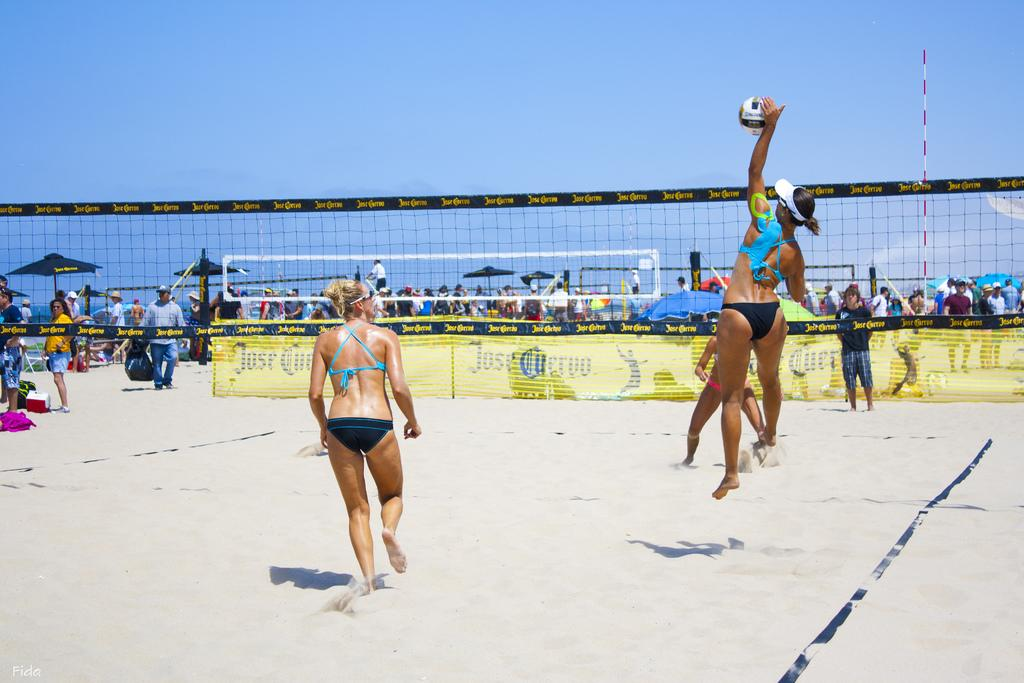What activity are the people in the center of the image engaged in? The people in the center of the image are playing volleyball. What can be observed in the background of the image? There are many people in the background of the image. Can you identify any specific objects or structures in the image? Yes, there is a pole visible in the image. What type of art is being displayed on the cake in the image? There is no cake present in the image, so it is not possible to answer that question. 